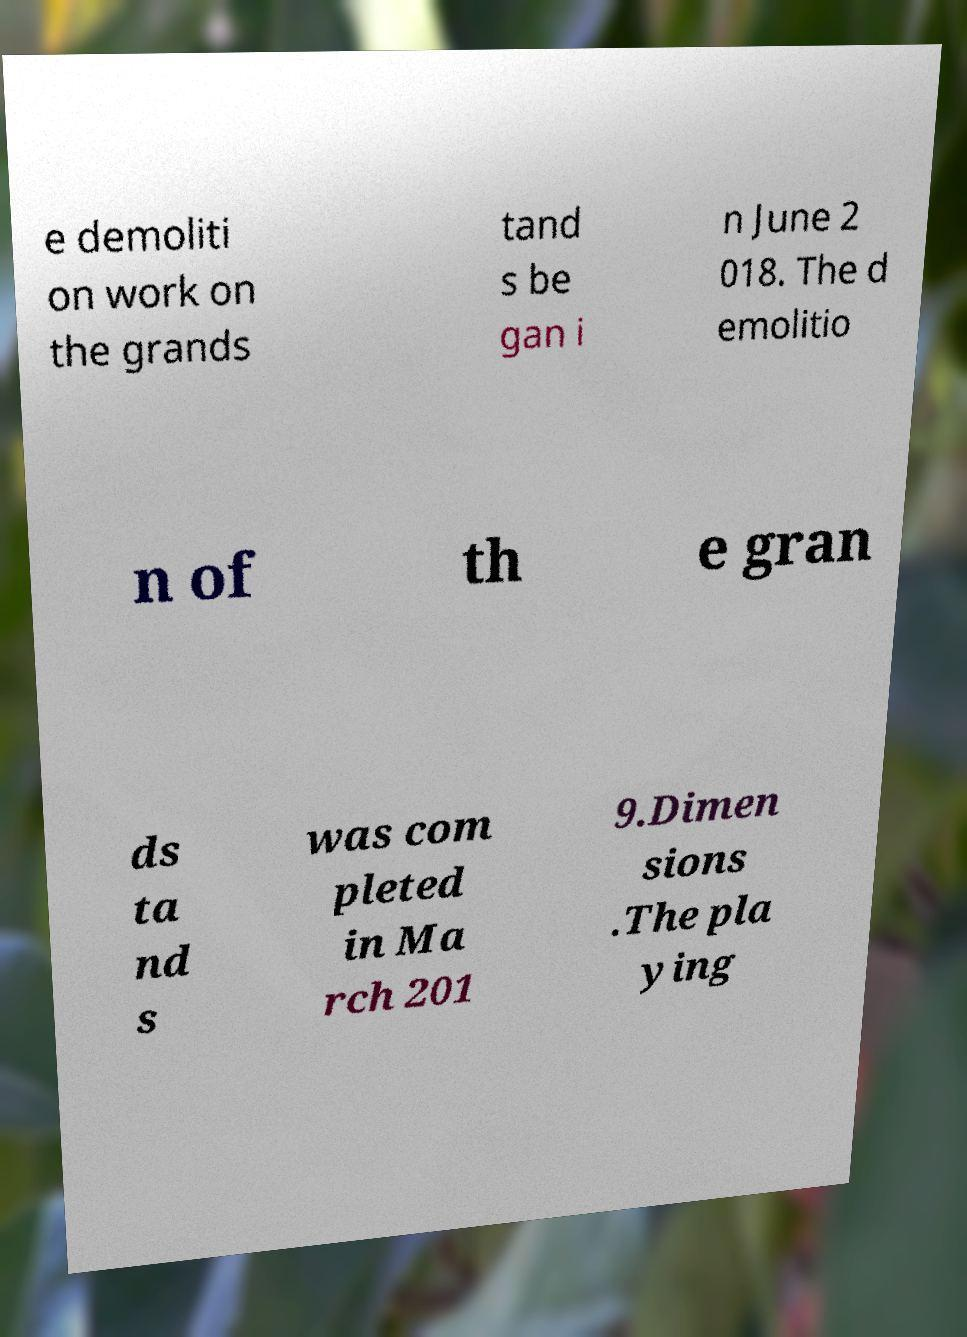Can you accurately transcribe the text from the provided image for me? e demoliti on work on the grands tand s be gan i n June 2 018. The d emolitio n of th e gran ds ta nd s was com pleted in Ma rch 201 9.Dimen sions .The pla ying 